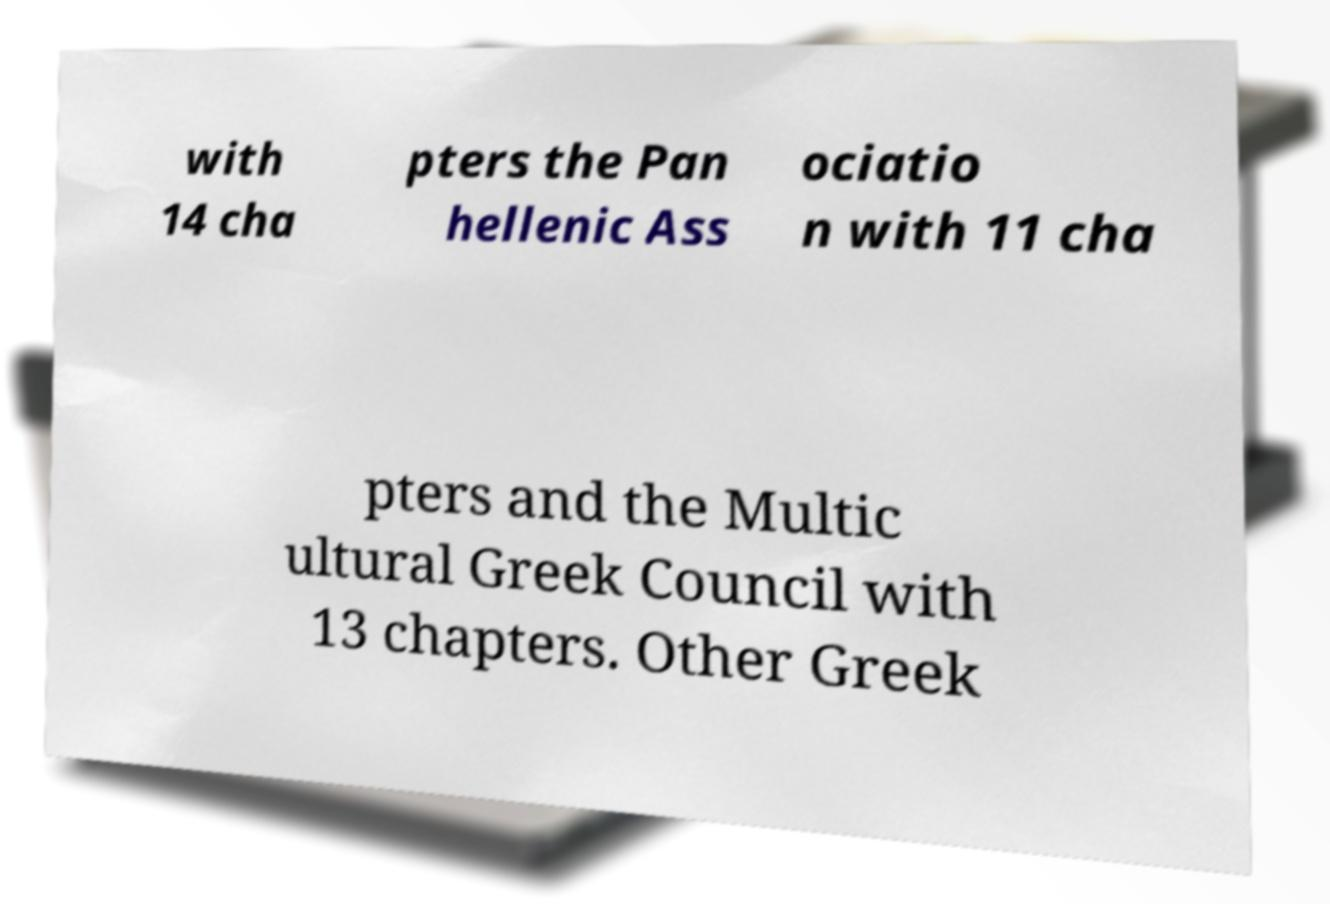Can you accurately transcribe the text from the provided image for me? with 14 cha pters the Pan hellenic Ass ociatio n with 11 cha pters and the Multic ultural Greek Council with 13 chapters. Other Greek 